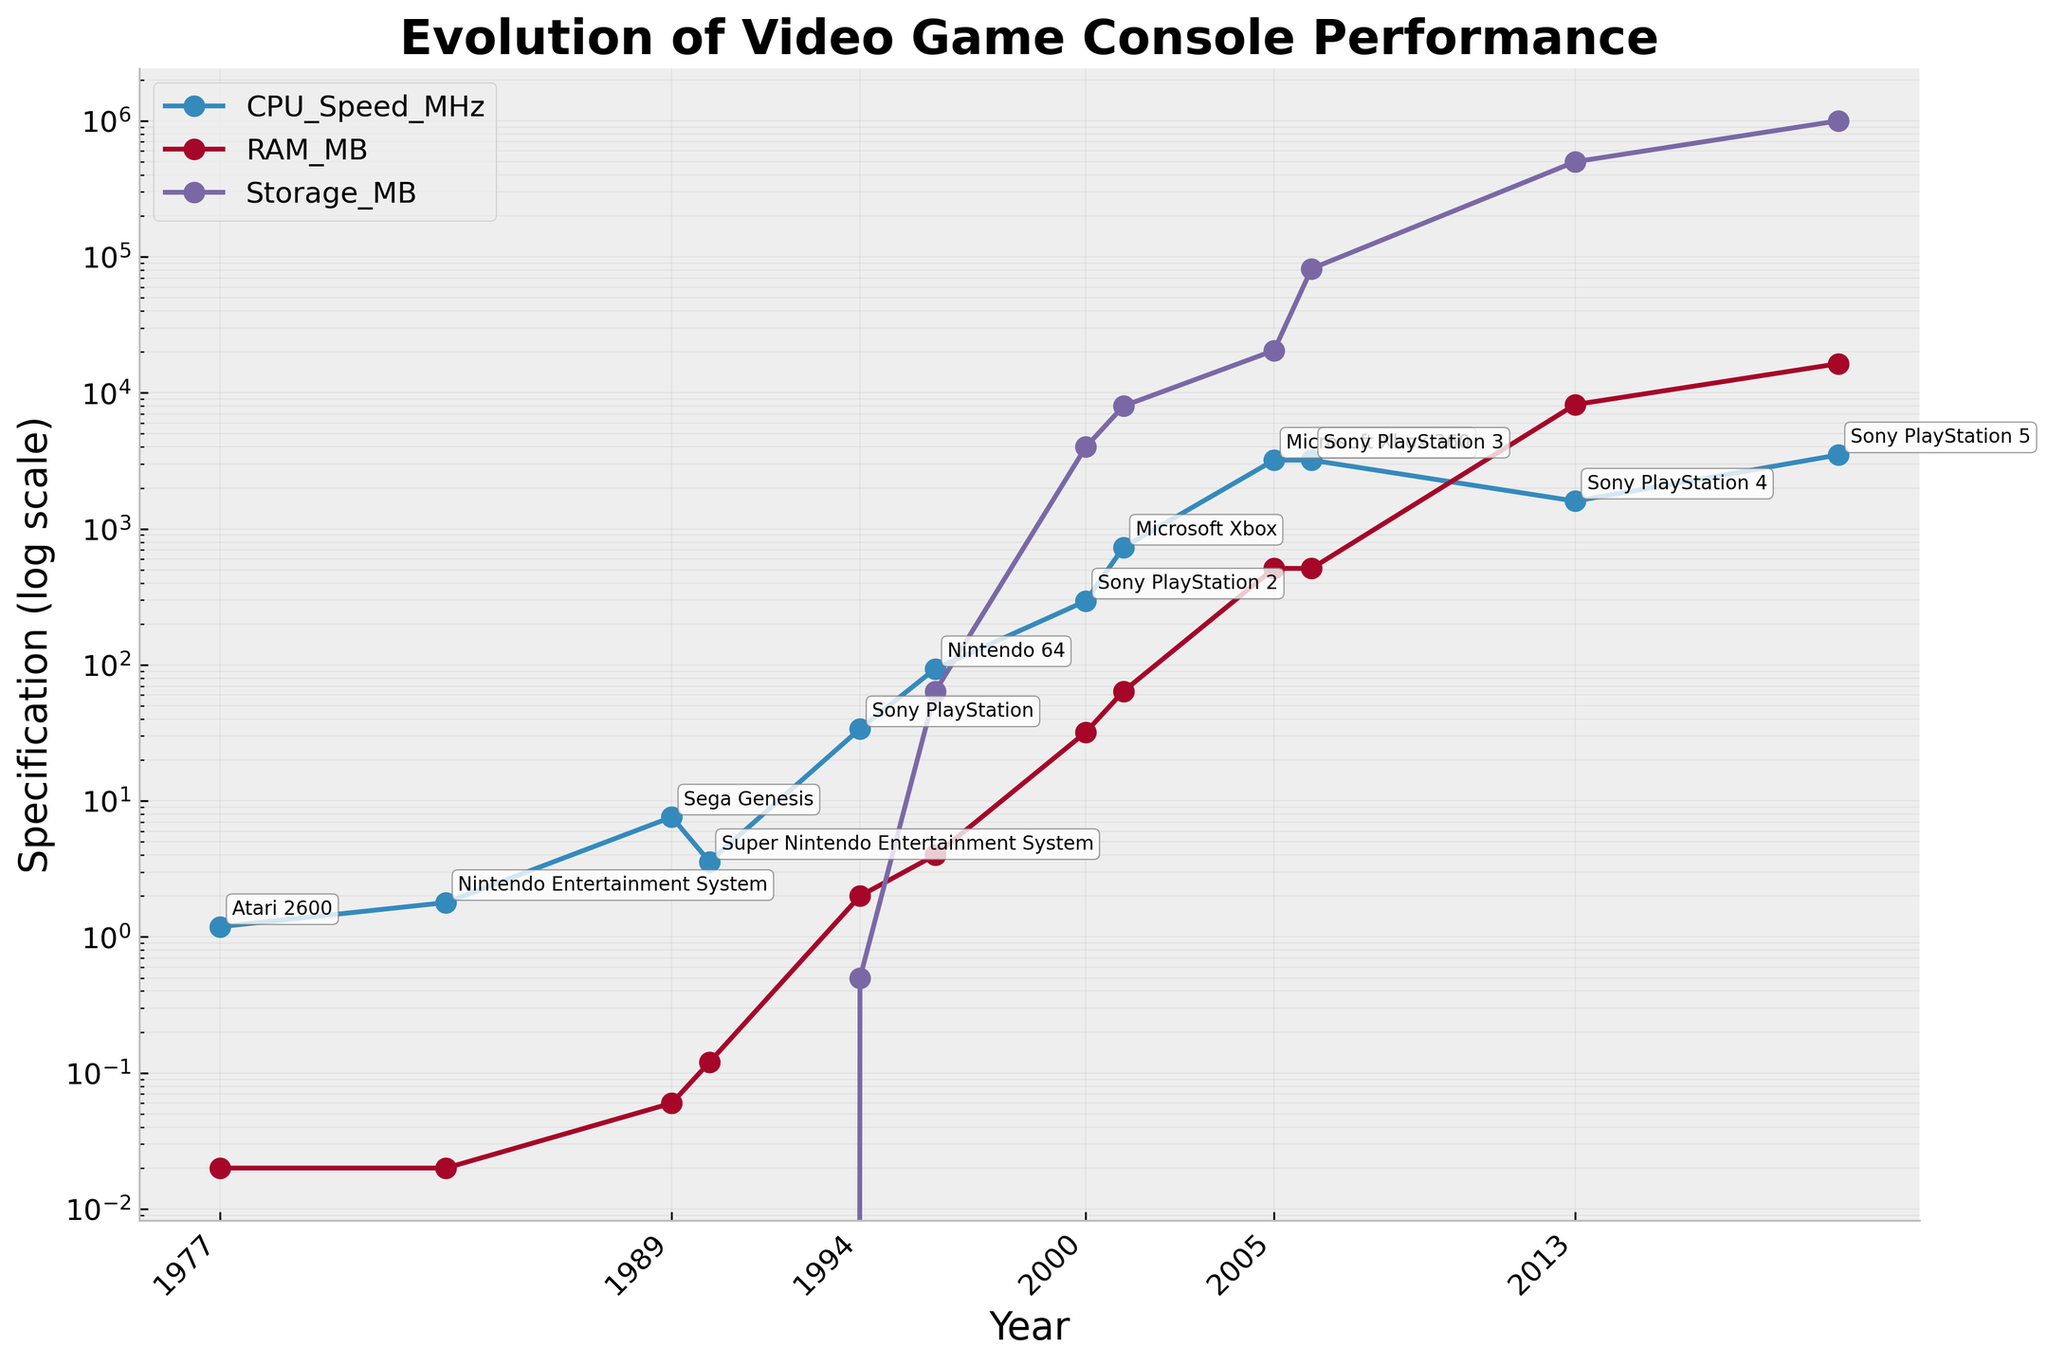What is the title of the figure? The title is usually located at the top of the figure. It summarizes what the figure is about. By reading the top part of the figure, you can see it says, "Evolution of Video Game Console Performance".
Answer: Evolution of Video Game Console Performance Which axis is in a log scale? To determine this, you can look at the axis labels and the tick marks. The Y-axis is labeled with "Specification (log scale)" and shows exponential values, indicating it is in a log scale.
Answer: Y-axis Which console has the highest CPU speed? To find this, look for the data point on the line corresponding to CPU Speed_MHz that is highest up on the Y-axis. The highest point corresponds to the Sony PlayStation 5.
Answer: Sony PlayStation 5 How does the RAM of Sony PlayStation 2 compare to Sony PlayStation 4? Locate the points for Sony PlayStation 2 and Sony PlayStation 4 on the line plot for RAM_MB. Sony PlayStation 2's RAM_MB is 32, whereas Sony PlayStation 4's RAM_MB is 8,192.
Answer: Sony PlayStation 4 has more RAM than Sony PlayStation 2 Which console introduced storage capacity in MB for the first time? Check for the earliest data point on the Storage_MB line that is not at zero. The earliest non-zero data point for Storage_MB corresponds to the Sony PlayStation in 1994.
Answer: Sony PlayStation What is the difference in CPU speed between the Microsoft Xbox and the Microsoft Xbox 360? Find the points for both consoles on the CPU Speed_MHz line. Microsoft Xbox has 733 MHz and Microsoft Xbox 360 has 3,200 MHz. Subtract these values: 3,200 MHz - 733 MHz = 2,467 MHz.
Answer: 2,467 MHz On the log scale, around which year does the RAM see a significant jump? Identify the RAM_MB line and look for a sharp increase in spacing between data points. The significant jump is observed around the year 2000 with the Sony PlayStation 2.
Answer: Around 2000 By what factor did the storage increase from Xbox 360 to PlayStation 5? Find the corresponding storage values. Xbox 360 has 20,480 MB and PlayStation 5 has 1,000,000 MB. Divide the larger by the smaller: 1,000,000 / 20,480 ≈ 48.83.
Answer: About 48.83 What is the trend of CPU speed over the years? Observe the line plot for CPU_Speed_MHz. It shows a consistent upward trend, with values increasing exponentially over time.
Answer: Consistent upward trend In which year did consoles start having more than 512 MB of RAM? Identify the point where the RAM_MB line crosses 512 MB. The first point above 512 MB is the PlayStation 4 in 2013.
Answer: 2013 